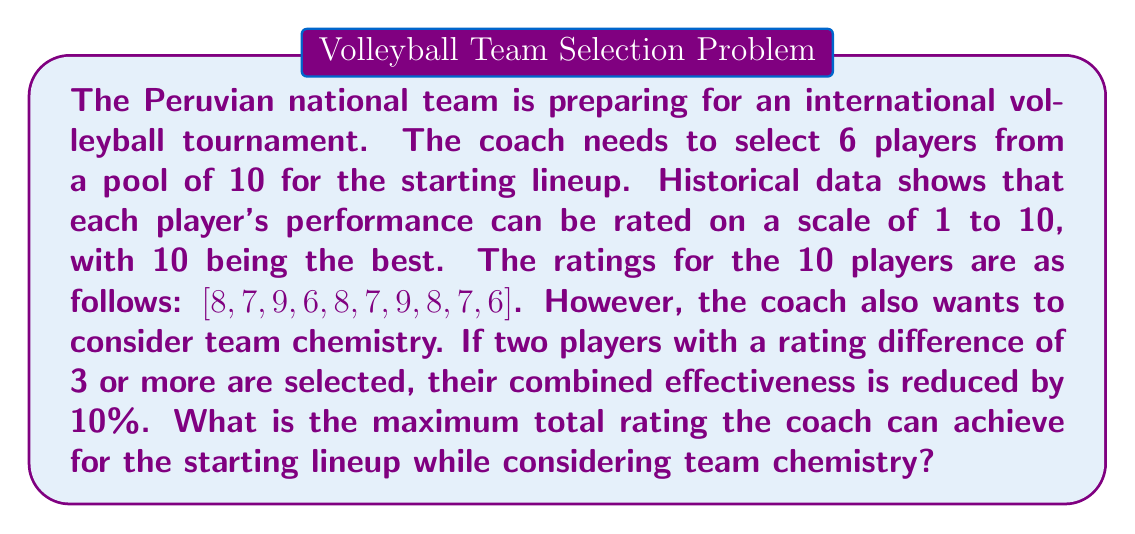Help me with this question. Let's approach this step-by-step:

1) First, we need to select the 6 highest-rated players:
   [9, 9, 8, 8, 8, 7]

2) The sum of these ratings is:
   $$9 + 9 + 8 + 8 + 8 + 7 = 49$$

3) Now, we need to check for pairs with a rating difference of 3 or more:
   The only such pair is 9 and 6 (difference of 3).

4) We need to calculate the reduction in effectiveness:
   $$\text{Reduction} = 10\% \times (9 + 6) = 1.5$$

5) Therefore, the total rating after considering team chemistry is:
   $$49 - 1.5 = 47.5$$

6) However, we can potentially improve this by replacing the 7 with the next highest rating (7) to avoid the chemistry penalty:
   [9, 9, 8, 8, 8, 7]
   This selection has no pairs with a rating difference of 3 or more.

7) The sum of these ratings is:
   $$9 + 9 + 8 + 8 + 8 + 7 = 49$$

8) Since 49 > 47.5, this is the optimal selection.
Answer: The maximum total rating the coach can achieve for the starting lineup while considering team chemistry is 49. 